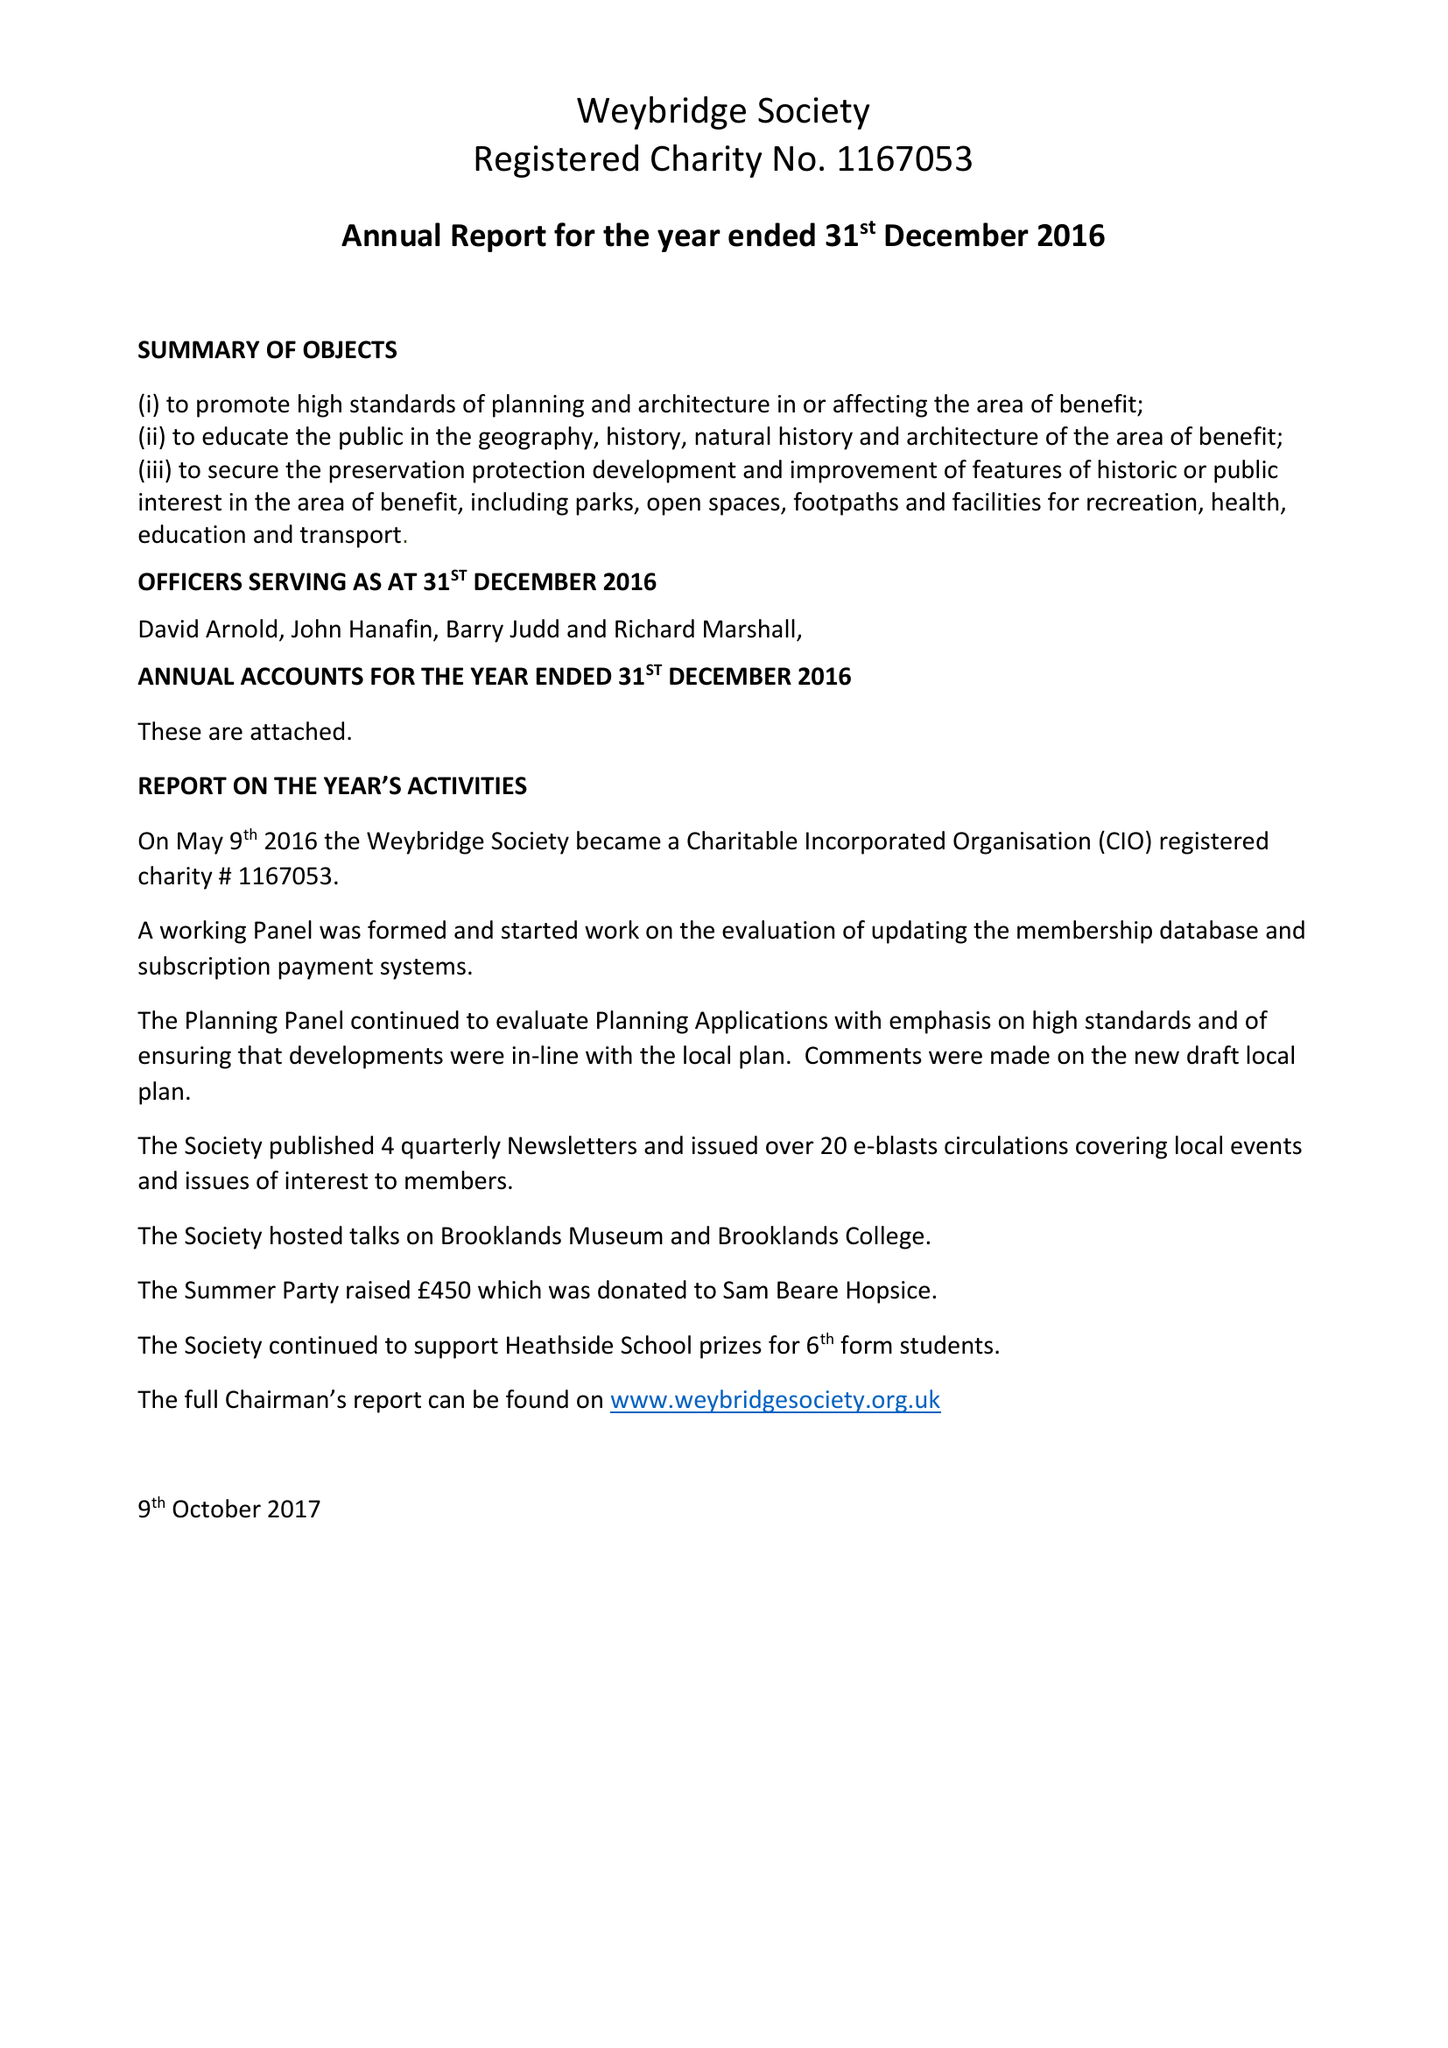What is the value for the spending_annually_in_british_pounds?
Answer the question using a single word or phrase. 3360.00 